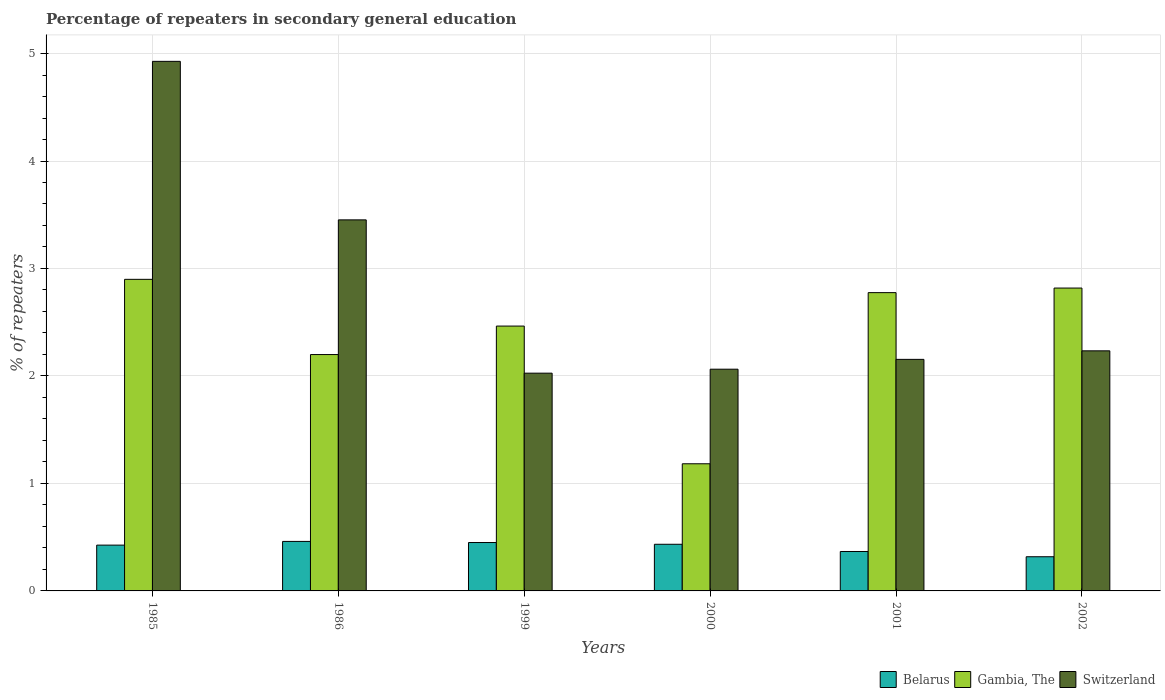How many different coloured bars are there?
Your response must be concise. 3. How many bars are there on the 2nd tick from the right?
Provide a short and direct response. 3. What is the label of the 1st group of bars from the left?
Your answer should be very brief. 1985. In how many cases, is the number of bars for a given year not equal to the number of legend labels?
Keep it short and to the point. 0. What is the percentage of repeaters in secondary general education in Gambia, The in 1986?
Make the answer very short. 2.2. Across all years, what is the maximum percentage of repeaters in secondary general education in Gambia, The?
Offer a very short reply. 2.9. Across all years, what is the minimum percentage of repeaters in secondary general education in Belarus?
Offer a terse response. 0.32. In which year was the percentage of repeaters in secondary general education in Switzerland maximum?
Make the answer very short. 1985. In which year was the percentage of repeaters in secondary general education in Gambia, The minimum?
Your answer should be compact. 2000. What is the total percentage of repeaters in secondary general education in Belarus in the graph?
Your answer should be compact. 2.46. What is the difference between the percentage of repeaters in secondary general education in Belarus in 2001 and that in 2002?
Keep it short and to the point. 0.05. What is the difference between the percentage of repeaters in secondary general education in Belarus in 1986 and the percentage of repeaters in secondary general education in Switzerland in 2001?
Provide a succinct answer. -1.69. What is the average percentage of repeaters in secondary general education in Gambia, The per year?
Make the answer very short. 2.39. In the year 2000, what is the difference between the percentage of repeaters in secondary general education in Gambia, The and percentage of repeaters in secondary general education in Belarus?
Your response must be concise. 0.75. In how many years, is the percentage of repeaters in secondary general education in Belarus greater than 0.8 %?
Make the answer very short. 0. What is the ratio of the percentage of repeaters in secondary general education in Belarus in 1985 to that in 2002?
Keep it short and to the point. 1.34. Is the difference between the percentage of repeaters in secondary general education in Gambia, The in 1985 and 1986 greater than the difference between the percentage of repeaters in secondary general education in Belarus in 1985 and 1986?
Your response must be concise. Yes. What is the difference between the highest and the second highest percentage of repeaters in secondary general education in Gambia, The?
Ensure brevity in your answer.  0.08. What is the difference between the highest and the lowest percentage of repeaters in secondary general education in Belarus?
Offer a terse response. 0.14. In how many years, is the percentage of repeaters in secondary general education in Gambia, The greater than the average percentage of repeaters in secondary general education in Gambia, The taken over all years?
Keep it short and to the point. 4. Is the sum of the percentage of repeaters in secondary general education in Switzerland in 2000 and 2001 greater than the maximum percentage of repeaters in secondary general education in Belarus across all years?
Give a very brief answer. Yes. What does the 2nd bar from the left in 1985 represents?
Offer a terse response. Gambia, The. What does the 2nd bar from the right in 1986 represents?
Provide a short and direct response. Gambia, The. How many years are there in the graph?
Your response must be concise. 6. Does the graph contain grids?
Ensure brevity in your answer.  Yes. Where does the legend appear in the graph?
Your response must be concise. Bottom right. How many legend labels are there?
Give a very brief answer. 3. How are the legend labels stacked?
Offer a very short reply. Horizontal. What is the title of the graph?
Make the answer very short. Percentage of repeaters in secondary general education. Does "Cote d'Ivoire" appear as one of the legend labels in the graph?
Provide a short and direct response. No. What is the label or title of the X-axis?
Offer a terse response. Years. What is the label or title of the Y-axis?
Offer a terse response. % of repeaters. What is the % of repeaters of Belarus in 1985?
Ensure brevity in your answer.  0.43. What is the % of repeaters in Gambia, The in 1985?
Offer a terse response. 2.9. What is the % of repeaters of Switzerland in 1985?
Your answer should be compact. 4.93. What is the % of repeaters of Belarus in 1986?
Offer a terse response. 0.46. What is the % of repeaters in Gambia, The in 1986?
Your answer should be very brief. 2.2. What is the % of repeaters in Switzerland in 1986?
Make the answer very short. 3.45. What is the % of repeaters of Belarus in 1999?
Offer a terse response. 0.45. What is the % of repeaters in Gambia, The in 1999?
Give a very brief answer. 2.46. What is the % of repeaters in Switzerland in 1999?
Your answer should be compact. 2.03. What is the % of repeaters of Belarus in 2000?
Your answer should be very brief. 0.43. What is the % of repeaters of Gambia, The in 2000?
Provide a short and direct response. 1.18. What is the % of repeaters in Switzerland in 2000?
Your answer should be compact. 2.06. What is the % of repeaters of Belarus in 2001?
Provide a short and direct response. 0.37. What is the % of repeaters of Gambia, The in 2001?
Keep it short and to the point. 2.78. What is the % of repeaters in Switzerland in 2001?
Keep it short and to the point. 2.15. What is the % of repeaters of Belarus in 2002?
Give a very brief answer. 0.32. What is the % of repeaters in Gambia, The in 2002?
Give a very brief answer. 2.82. What is the % of repeaters of Switzerland in 2002?
Ensure brevity in your answer.  2.23. Across all years, what is the maximum % of repeaters in Belarus?
Offer a terse response. 0.46. Across all years, what is the maximum % of repeaters of Gambia, The?
Offer a very short reply. 2.9. Across all years, what is the maximum % of repeaters of Switzerland?
Your answer should be compact. 4.93. Across all years, what is the minimum % of repeaters in Belarus?
Offer a terse response. 0.32. Across all years, what is the minimum % of repeaters of Gambia, The?
Keep it short and to the point. 1.18. Across all years, what is the minimum % of repeaters of Switzerland?
Provide a short and direct response. 2.03. What is the total % of repeaters in Belarus in the graph?
Offer a very short reply. 2.46. What is the total % of repeaters in Gambia, The in the graph?
Your answer should be very brief. 14.34. What is the total % of repeaters of Switzerland in the graph?
Your answer should be compact. 16.86. What is the difference between the % of repeaters in Belarus in 1985 and that in 1986?
Provide a succinct answer. -0.03. What is the difference between the % of repeaters in Gambia, The in 1985 and that in 1986?
Give a very brief answer. 0.7. What is the difference between the % of repeaters of Switzerland in 1985 and that in 1986?
Your response must be concise. 1.47. What is the difference between the % of repeaters in Belarus in 1985 and that in 1999?
Offer a terse response. -0.02. What is the difference between the % of repeaters in Gambia, The in 1985 and that in 1999?
Give a very brief answer. 0.43. What is the difference between the % of repeaters in Switzerland in 1985 and that in 1999?
Keep it short and to the point. 2.9. What is the difference between the % of repeaters of Belarus in 1985 and that in 2000?
Your answer should be very brief. -0.01. What is the difference between the % of repeaters in Gambia, The in 1985 and that in 2000?
Give a very brief answer. 1.72. What is the difference between the % of repeaters in Switzerland in 1985 and that in 2000?
Offer a very short reply. 2.86. What is the difference between the % of repeaters of Belarus in 1985 and that in 2001?
Make the answer very short. 0.06. What is the difference between the % of repeaters of Gambia, The in 1985 and that in 2001?
Provide a short and direct response. 0.12. What is the difference between the % of repeaters in Switzerland in 1985 and that in 2001?
Provide a short and direct response. 2.77. What is the difference between the % of repeaters of Belarus in 1985 and that in 2002?
Provide a short and direct response. 0.11. What is the difference between the % of repeaters of Gambia, The in 1985 and that in 2002?
Provide a succinct answer. 0.08. What is the difference between the % of repeaters in Switzerland in 1985 and that in 2002?
Offer a very short reply. 2.69. What is the difference between the % of repeaters in Belarus in 1986 and that in 1999?
Your response must be concise. 0.01. What is the difference between the % of repeaters in Gambia, The in 1986 and that in 1999?
Offer a terse response. -0.27. What is the difference between the % of repeaters in Switzerland in 1986 and that in 1999?
Offer a very short reply. 1.43. What is the difference between the % of repeaters in Belarus in 1986 and that in 2000?
Offer a terse response. 0.03. What is the difference between the % of repeaters in Gambia, The in 1986 and that in 2000?
Give a very brief answer. 1.02. What is the difference between the % of repeaters in Switzerland in 1986 and that in 2000?
Offer a very short reply. 1.39. What is the difference between the % of repeaters of Belarus in 1986 and that in 2001?
Provide a short and direct response. 0.09. What is the difference between the % of repeaters of Gambia, The in 1986 and that in 2001?
Keep it short and to the point. -0.58. What is the difference between the % of repeaters in Switzerland in 1986 and that in 2001?
Your answer should be compact. 1.3. What is the difference between the % of repeaters in Belarus in 1986 and that in 2002?
Offer a terse response. 0.14. What is the difference between the % of repeaters of Gambia, The in 1986 and that in 2002?
Your response must be concise. -0.62. What is the difference between the % of repeaters of Switzerland in 1986 and that in 2002?
Your response must be concise. 1.22. What is the difference between the % of repeaters in Belarus in 1999 and that in 2000?
Offer a terse response. 0.02. What is the difference between the % of repeaters of Gambia, The in 1999 and that in 2000?
Your answer should be very brief. 1.28. What is the difference between the % of repeaters in Switzerland in 1999 and that in 2000?
Give a very brief answer. -0.04. What is the difference between the % of repeaters of Belarus in 1999 and that in 2001?
Offer a very short reply. 0.08. What is the difference between the % of repeaters of Gambia, The in 1999 and that in 2001?
Offer a very short reply. -0.31. What is the difference between the % of repeaters in Switzerland in 1999 and that in 2001?
Offer a very short reply. -0.13. What is the difference between the % of repeaters of Belarus in 1999 and that in 2002?
Your answer should be very brief. 0.13. What is the difference between the % of repeaters in Gambia, The in 1999 and that in 2002?
Keep it short and to the point. -0.35. What is the difference between the % of repeaters in Switzerland in 1999 and that in 2002?
Keep it short and to the point. -0.21. What is the difference between the % of repeaters of Belarus in 2000 and that in 2001?
Give a very brief answer. 0.07. What is the difference between the % of repeaters of Gambia, The in 2000 and that in 2001?
Your answer should be compact. -1.59. What is the difference between the % of repeaters of Switzerland in 2000 and that in 2001?
Make the answer very short. -0.09. What is the difference between the % of repeaters of Belarus in 2000 and that in 2002?
Keep it short and to the point. 0.12. What is the difference between the % of repeaters in Gambia, The in 2000 and that in 2002?
Offer a terse response. -1.64. What is the difference between the % of repeaters in Switzerland in 2000 and that in 2002?
Provide a succinct answer. -0.17. What is the difference between the % of repeaters of Belarus in 2001 and that in 2002?
Your answer should be very brief. 0.05. What is the difference between the % of repeaters of Gambia, The in 2001 and that in 2002?
Ensure brevity in your answer.  -0.04. What is the difference between the % of repeaters of Switzerland in 2001 and that in 2002?
Give a very brief answer. -0.08. What is the difference between the % of repeaters in Belarus in 1985 and the % of repeaters in Gambia, The in 1986?
Provide a short and direct response. -1.77. What is the difference between the % of repeaters in Belarus in 1985 and the % of repeaters in Switzerland in 1986?
Ensure brevity in your answer.  -3.03. What is the difference between the % of repeaters in Gambia, The in 1985 and the % of repeaters in Switzerland in 1986?
Ensure brevity in your answer.  -0.55. What is the difference between the % of repeaters in Belarus in 1985 and the % of repeaters in Gambia, The in 1999?
Offer a terse response. -2.04. What is the difference between the % of repeaters in Belarus in 1985 and the % of repeaters in Switzerland in 1999?
Your answer should be very brief. -1.6. What is the difference between the % of repeaters of Gambia, The in 1985 and the % of repeaters of Switzerland in 1999?
Keep it short and to the point. 0.87. What is the difference between the % of repeaters of Belarus in 1985 and the % of repeaters of Gambia, The in 2000?
Your answer should be very brief. -0.76. What is the difference between the % of repeaters in Belarus in 1985 and the % of repeaters in Switzerland in 2000?
Provide a short and direct response. -1.64. What is the difference between the % of repeaters in Gambia, The in 1985 and the % of repeaters in Switzerland in 2000?
Ensure brevity in your answer.  0.84. What is the difference between the % of repeaters of Belarus in 1985 and the % of repeaters of Gambia, The in 2001?
Give a very brief answer. -2.35. What is the difference between the % of repeaters of Belarus in 1985 and the % of repeaters of Switzerland in 2001?
Offer a very short reply. -1.73. What is the difference between the % of repeaters of Gambia, The in 1985 and the % of repeaters of Switzerland in 2001?
Provide a succinct answer. 0.74. What is the difference between the % of repeaters in Belarus in 1985 and the % of repeaters in Gambia, The in 2002?
Your answer should be compact. -2.39. What is the difference between the % of repeaters of Belarus in 1985 and the % of repeaters of Switzerland in 2002?
Your answer should be very brief. -1.81. What is the difference between the % of repeaters of Gambia, The in 1985 and the % of repeaters of Switzerland in 2002?
Make the answer very short. 0.67. What is the difference between the % of repeaters of Belarus in 1986 and the % of repeaters of Gambia, The in 1999?
Ensure brevity in your answer.  -2. What is the difference between the % of repeaters of Belarus in 1986 and the % of repeaters of Switzerland in 1999?
Ensure brevity in your answer.  -1.57. What is the difference between the % of repeaters in Gambia, The in 1986 and the % of repeaters in Switzerland in 1999?
Give a very brief answer. 0.17. What is the difference between the % of repeaters of Belarus in 1986 and the % of repeaters of Gambia, The in 2000?
Make the answer very short. -0.72. What is the difference between the % of repeaters in Belarus in 1986 and the % of repeaters in Switzerland in 2000?
Provide a short and direct response. -1.6. What is the difference between the % of repeaters in Gambia, The in 1986 and the % of repeaters in Switzerland in 2000?
Your answer should be compact. 0.14. What is the difference between the % of repeaters of Belarus in 1986 and the % of repeaters of Gambia, The in 2001?
Provide a short and direct response. -2.31. What is the difference between the % of repeaters of Belarus in 1986 and the % of repeaters of Switzerland in 2001?
Offer a very short reply. -1.69. What is the difference between the % of repeaters in Gambia, The in 1986 and the % of repeaters in Switzerland in 2001?
Give a very brief answer. 0.04. What is the difference between the % of repeaters of Belarus in 1986 and the % of repeaters of Gambia, The in 2002?
Ensure brevity in your answer.  -2.36. What is the difference between the % of repeaters in Belarus in 1986 and the % of repeaters in Switzerland in 2002?
Your answer should be compact. -1.77. What is the difference between the % of repeaters in Gambia, The in 1986 and the % of repeaters in Switzerland in 2002?
Provide a succinct answer. -0.03. What is the difference between the % of repeaters in Belarus in 1999 and the % of repeaters in Gambia, The in 2000?
Provide a succinct answer. -0.73. What is the difference between the % of repeaters in Belarus in 1999 and the % of repeaters in Switzerland in 2000?
Your response must be concise. -1.61. What is the difference between the % of repeaters of Gambia, The in 1999 and the % of repeaters of Switzerland in 2000?
Make the answer very short. 0.4. What is the difference between the % of repeaters in Belarus in 1999 and the % of repeaters in Gambia, The in 2001?
Provide a succinct answer. -2.33. What is the difference between the % of repeaters of Belarus in 1999 and the % of repeaters of Switzerland in 2001?
Your response must be concise. -1.7. What is the difference between the % of repeaters in Gambia, The in 1999 and the % of repeaters in Switzerland in 2001?
Offer a very short reply. 0.31. What is the difference between the % of repeaters in Belarus in 1999 and the % of repeaters in Gambia, The in 2002?
Your answer should be compact. -2.37. What is the difference between the % of repeaters in Belarus in 1999 and the % of repeaters in Switzerland in 2002?
Ensure brevity in your answer.  -1.78. What is the difference between the % of repeaters in Gambia, The in 1999 and the % of repeaters in Switzerland in 2002?
Provide a succinct answer. 0.23. What is the difference between the % of repeaters in Belarus in 2000 and the % of repeaters in Gambia, The in 2001?
Provide a succinct answer. -2.34. What is the difference between the % of repeaters in Belarus in 2000 and the % of repeaters in Switzerland in 2001?
Offer a very short reply. -1.72. What is the difference between the % of repeaters in Gambia, The in 2000 and the % of repeaters in Switzerland in 2001?
Provide a short and direct response. -0.97. What is the difference between the % of repeaters in Belarus in 2000 and the % of repeaters in Gambia, The in 2002?
Your response must be concise. -2.38. What is the difference between the % of repeaters in Belarus in 2000 and the % of repeaters in Switzerland in 2002?
Provide a succinct answer. -1.8. What is the difference between the % of repeaters of Gambia, The in 2000 and the % of repeaters of Switzerland in 2002?
Your response must be concise. -1.05. What is the difference between the % of repeaters in Belarus in 2001 and the % of repeaters in Gambia, The in 2002?
Your answer should be compact. -2.45. What is the difference between the % of repeaters in Belarus in 2001 and the % of repeaters in Switzerland in 2002?
Offer a terse response. -1.87. What is the difference between the % of repeaters in Gambia, The in 2001 and the % of repeaters in Switzerland in 2002?
Offer a very short reply. 0.54. What is the average % of repeaters in Belarus per year?
Your answer should be compact. 0.41. What is the average % of repeaters of Gambia, The per year?
Provide a succinct answer. 2.39. What is the average % of repeaters of Switzerland per year?
Ensure brevity in your answer.  2.81. In the year 1985, what is the difference between the % of repeaters in Belarus and % of repeaters in Gambia, The?
Ensure brevity in your answer.  -2.47. In the year 1985, what is the difference between the % of repeaters of Belarus and % of repeaters of Switzerland?
Your response must be concise. -4.5. In the year 1985, what is the difference between the % of repeaters of Gambia, The and % of repeaters of Switzerland?
Provide a short and direct response. -2.03. In the year 1986, what is the difference between the % of repeaters in Belarus and % of repeaters in Gambia, The?
Offer a terse response. -1.74. In the year 1986, what is the difference between the % of repeaters of Belarus and % of repeaters of Switzerland?
Offer a terse response. -2.99. In the year 1986, what is the difference between the % of repeaters of Gambia, The and % of repeaters of Switzerland?
Make the answer very short. -1.25. In the year 1999, what is the difference between the % of repeaters of Belarus and % of repeaters of Gambia, The?
Your response must be concise. -2.01. In the year 1999, what is the difference between the % of repeaters of Belarus and % of repeaters of Switzerland?
Make the answer very short. -1.58. In the year 1999, what is the difference between the % of repeaters in Gambia, The and % of repeaters in Switzerland?
Your response must be concise. 0.44. In the year 2000, what is the difference between the % of repeaters of Belarus and % of repeaters of Gambia, The?
Your answer should be very brief. -0.75. In the year 2000, what is the difference between the % of repeaters of Belarus and % of repeaters of Switzerland?
Offer a very short reply. -1.63. In the year 2000, what is the difference between the % of repeaters in Gambia, The and % of repeaters in Switzerland?
Make the answer very short. -0.88. In the year 2001, what is the difference between the % of repeaters of Belarus and % of repeaters of Gambia, The?
Give a very brief answer. -2.41. In the year 2001, what is the difference between the % of repeaters in Belarus and % of repeaters in Switzerland?
Make the answer very short. -1.79. In the year 2001, what is the difference between the % of repeaters of Gambia, The and % of repeaters of Switzerland?
Provide a short and direct response. 0.62. In the year 2002, what is the difference between the % of repeaters in Belarus and % of repeaters in Switzerland?
Your answer should be compact. -1.92. In the year 2002, what is the difference between the % of repeaters in Gambia, The and % of repeaters in Switzerland?
Offer a very short reply. 0.58. What is the ratio of the % of repeaters in Belarus in 1985 to that in 1986?
Your answer should be very brief. 0.93. What is the ratio of the % of repeaters in Gambia, The in 1985 to that in 1986?
Provide a short and direct response. 1.32. What is the ratio of the % of repeaters in Switzerland in 1985 to that in 1986?
Ensure brevity in your answer.  1.43. What is the ratio of the % of repeaters of Belarus in 1985 to that in 1999?
Keep it short and to the point. 0.95. What is the ratio of the % of repeaters of Gambia, The in 1985 to that in 1999?
Keep it short and to the point. 1.18. What is the ratio of the % of repeaters in Switzerland in 1985 to that in 1999?
Give a very brief answer. 2.43. What is the ratio of the % of repeaters in Belarus in 1985 to that in 2000?
Offer a very short reply. 0.98. What is the ratio of the % of repeaters in Gambia, The in 1985 to that in 2000?
Provide a short and direct response. 2.45. What is the ratio of the % of repeaters in Switzerland in 1985 to that in 2000?
Offer a terse response. 2.39. What is the ratio of the % of repeaters in Belarus in 1985 to that in 2001?
Your answer should be compact. 1.16. What is the ratio of the % of repeaters of Gambia, The in 1985 to that in 2001?
Make the answer very short. 1.04. What is the ratio of the % of repeaters of Switzerland in 1985 to that in 2001?
Provide a short and direct response. 2.29. What is the ratio of the % of repeaters in Belarus in 1985 to that in 2002?
Provide a succinct answer. 1.34. What is the ratio of the % of repeaters in Gambia, The in 1985 to that in 2002?
Ensure brevity in your answer.  1.03. What is the ratio of the % of repeaters of Switzerland in 1985 to that in 2002?
Offer a very short reply. 2.21. What is the ratio of the % of repeaters of Belarus in 1986 to that in 1999?
Your answer should be compact. 1.02. What is the ratio of the % of repeaters of Gambia, The in 1986 to that in 1999?
Keep it short and to the point. 0.89. What is the ratio of the % of repeaters of Switzerland in 1986 to that in 1999?
Offer a terse response. 1.7. What is the ratio of the % of repeaters of Belarus in 1986 to that in 2000?
Provide a short and direct response. 1.06. What is the ratio of the % of repeaters of Gambia, The in 1986 to that in 2000?
Offer a very short reply. 1.86. What is the ratio of the % of repeaters in Switzerland in 1986 to that in 2000?
Your response must be concise. 1.67. What is the ratio of the % of repeaters of Belarus in 1986 to that in 2001?
Your answer should be compact. 1.26. What is the ratio of the % of repeaters of Gambia, The in 1986 to that in 2001?
Make the answer very short. 0.79. What is the ratio of the % of repeaters in Switzerland in 1986 to that in 2001?
Offer a terse response. 1.6. What is the ratio of the % of repeaters of Belarus in 1986 to that in 2002?
Your response must be concise. 1.45. What is the ratio of the % of repeaters in Gambia, The in 1986 to that in 2002?
Provide a short and direct response. 0.78. What is the ratio of the % of repeaters of Switzerland in 1986 to that in 2002?
Offer a very short reply. 1.55. What is the ratio of the % of repeaters of Belarus in 1999 to that in 2000?
Provide a succinct answer. 1.04. What is the ratio of the % of repeaters in Gambia, The in 1999 to that in 2000?
Give a very brief answer. 2.08. What is the ratio of the % of repeaters of Switzerland in 1999 to that in 2000?
Offer a very short reply. 0.98. What is the ratio of the % of repeaters in Belarus in 1999 to that in 2001?
Give a very brief answer. 1.23. What is the ratio of the % of repeaters in Gambia, The in 1999 to that in 2001?
Offer a very short reply. 0.89. What is the ratio of the % of repeaters of Switzerland in 1999 to that in 2001?
Your answer should be compact. 0.94. What is the ratio of the % of repeaters in Belarus in 1999 to that in 2002?
Your response must be concise. 1.42. What is the ratio of the % of repeaters of Gambia, The in 1999 to that in 2002?
Give a very brief answer. 0.87. What is the ratio of the % of repeaters of Switzerland in 1999 to that in 2002?
Offer a terse response. 0.91. What is the ratio of the % of repeaters in Belarus in 2000 to that in 2001?
Offer a terse response. 1.18. What is the ratio of the % of repeaters in Gambia, The in 2000 to that in 2001?
Your answer should be compact. 0.43. What is the ratio of the % of repeaters of Switzerland in 2000 to that in 2001?
Give a very brief answer. 0.96. What is the ratio of the % of repeaters of Belarus in 2000 to that in 2002?
Ensure brevity in your answer.  1.36. What is the ratio of the % of repeaters of Gambia, The in 2000 to that in 2002?
Offer a terse response. 0.42. What is the ratio of the % of repeaters of Switzerland in 2000 to that in 2002?
Provide a succinct answer. 0.92. What is the ratio of the % of repeaters in Belarus in 2001 to that in 2002?
Your answer should be compact. 1.15. What is the ratio of the % of repeaters of Gambia, The in 2001 to that in 2002?
Provide a succinct answer. 0.98. What is the ratio of the % of repeaters in Switzerland in 2001 to that in 2002?
Provide a short and direct response. 0.96. What is the difference between the highest and the second highest % of repeaters of Belarus?
Ensure brevity in your answer.  0.01. What is the difference between the highest and the second highest % of repeaters in Gambia, The?
Ensure brevity in your answer.  0.08. What is the difference between the highest and the second highest % of repeaters of Switzerland?
Ensure brevity in your answer.  1.47. What is the difference between the highest and the lowest % of repeaters in Belarus?
Offer a very short reply. 0.14. What is the difference between the highest and the lowest % of repeaters in Gambia, The?
Your response must be concise. 1.72. What is the difference between the highest and the lowest % of repeaters in Switzerland?
Offer a very short reply. 2.9. 